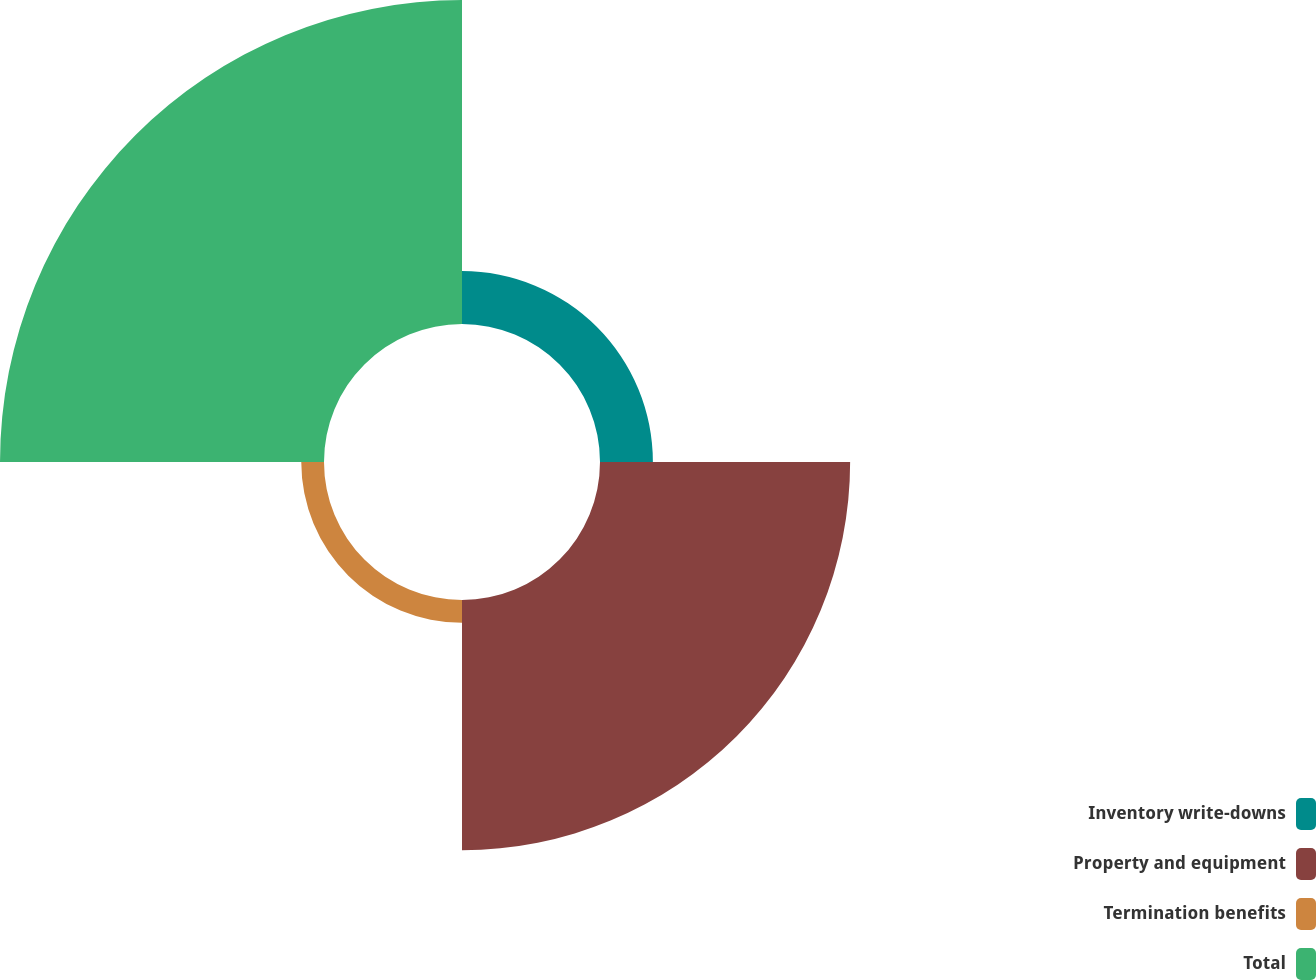Convert chart. <chart><loc_0><loc_0><loc_500><loc_500><pie_chart><fcel>Inventory write-downs<fcel>Property and equipment<fcel>Termination benefits<fcel>Total<nl><fcel>8.14%<fcel>38.5%<fcel>3.5%<fcel>49.87%<nl></chart> 